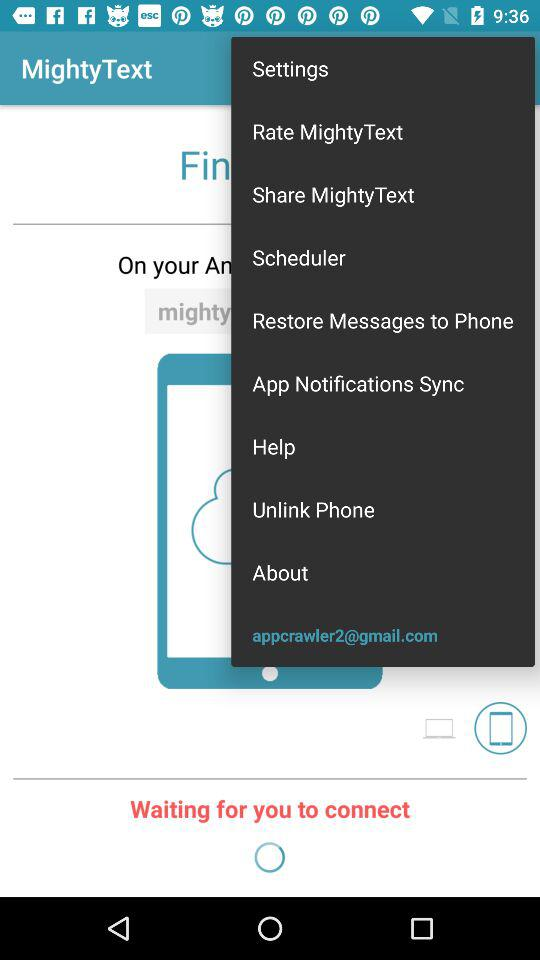What is the user name? The user name is App Crawler. 